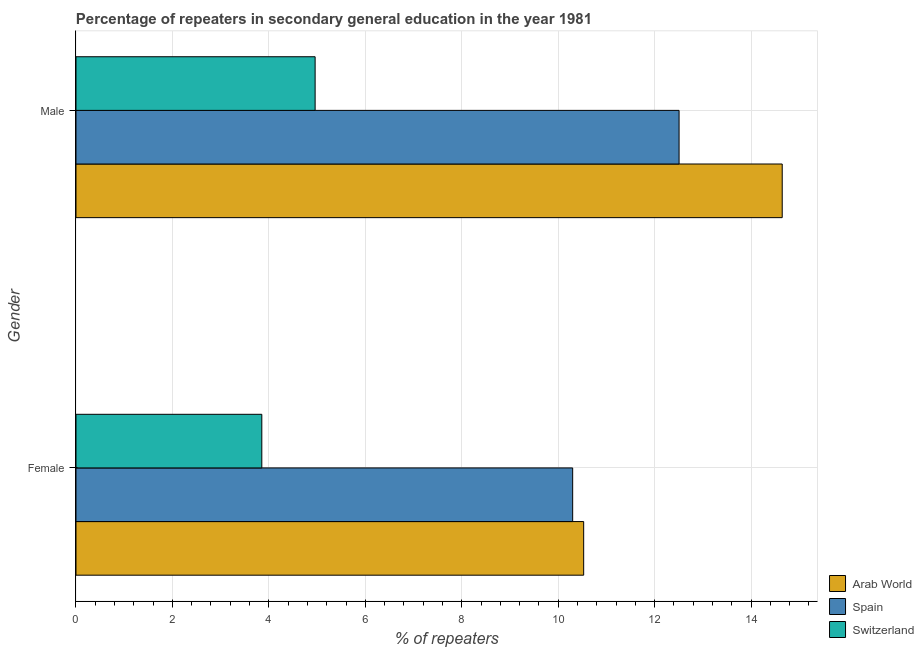How many groups of bars are there?
Your answer should be very brief. 2. How many bars are there on the 2nd tick from the top?
Give a very brief answer. 3. What is the percentage of female repeaters in Arab World?
Ensure brevity in your answer.  10.53. Across all countries, what is the maximum percentage of female repeaters?
Give a very brief answer. 10.53. Across all countries, what is the minimum percentage of female repeaters?
Ensure brevity in your answer.  3.85. In which country was the percentage of male repeaters maximum?
Your response must be concise. Arab World. In which country was the percentage of male repeaters minimum?
Offer a very short reply. Switzerland. What is the total percentage of male repeaters in the graph?
Offer a very short reply. 32.12. What is the difference between the percentage of female repeaters in Switzerland and that in Spain?
Your answer should be compact. -6.45. What is the difference between the percentage of female repeaters in Spain and the percentage of male repeaters in Switzerland?
Offer a very short reply. 5.34. What is the average percentage of female repeaters per country?
Your answer should be compact. 8.23. What is the difference between the percentage of female repeaters and percentage of male repeaters in Arab World?
Provide a succinct answer. -4.12. What is the ratio of the percentage of female repeaters in Spain to that in Switzerland?
Provide a succinct answer. 2.67. Is the percentage of male repeaters in Spain less than that in Switzerland?
Keep it short and to the point. No. What does the 1st bar from the top in Male represents?
Ensure brevity in your answer.  Switzerland. What does the 3rd bar from the bottom in Female represents?
Provide a succinct answer. Switzerland. How many countries are there in the graph?
Your answer should be very brief. 3. What is the difference between two consecutive major ticks on the X-axis?
Keep it short and to the point. 2. Are the values on the major ticks of X-axis written in scientific E-notation?
Your answer should be compact. No. Does the graph contain any zero values?
Make the answer very short. No. Where does the legend appear in the graph?
Ensure brevity in your answer.  Bottom right. How many legend labels are there?
Provide a short and direct response. 3. How are the legend labels stacked?
Make the answer very short. Vertical. What is the title of the graph?
Your response must be concise. Percentage of repeaters in secondary general education in the year 1981. What is the label or title of the X-axis?
Keep it short and to the point. % of repeaters. What is the label or title of the Y-axis?
Your answer should be compact. Gender. What is the % of repeaters in Arab World in Female?
Make the answer very short. 10.53. What is the % of repeaters of Spain in Female?
Offer a very short reply. 10.3. What is the % of repeaters in Switzerland in Female?
Provide a succinct answer. 3.85. What is the % of repeaters of Arab World in Male?
Your answer should be compact. 14.65. What is the % of repeaters of Spain in Male?
Give a very brief answer. 12.51. What is the % of repeaters in Switzerland in Male?
Provide a short and direct response. 4.96. Across all Gender, what is the maximum % of repeaters in Arab World?
Provide a succinct answer. 14.65. Across all Gender, what is the maximum % of repeaters in Spain?
Provide a succinct answer. 12.51. Across all Gender, what is the maximum % of repeaters of Switzerland?
Ensure brevity in your answer.  4.96. Across all Gender, what is the minimum % of repeaters in Arab World?
Offer a very short reply. 10.53. Across all Gender, what is the minimum % of repeaters of Spain?
Make the answer very short. 10.3. Across all Gender, what is the minimum % of repeaters of Switzerland?
Provide a succinct answer. 3.85. What is the total % of repeaters of Arab World in the graph?
Your answer should be compact. 25.18. What is the total % of repeaters of Spain in the graph?
Give a very brief answer. 22.81. What is the total % of repeaters in Switzerland in the graph?
Provide a short and direct response. 8.81. What is the difference between the % of repeaters of Arab World in Female and that in Male?
Your answer should be very brief. -4.12. What is the difference between the % of repeaters of Spain in Female and that in Male?
Keep it short and to the point. -2.21. What is the difference between the % of repeaters in Switzerland in Female and that in Male?
Offer a terse response. -1.11. What is the difference between the % of repeaters in Arab World in Female and the % of repeaters in Spain in Male?
Ensure brevity in your answer.  -1.98. What is the difference between the % of repeaters in Arab World in Female and the % of repeaters in Switzerland in Male?
Offer a terse response. 5.57. What is the difference between the % of repeaters in Spain in Female and the % of repeaters in Switzerland in Male?
Your response must be concise. 5.34. What is the average % of repeaters of Arab World per Gender?
Give a very brief answer. 12.59. What is the average % of repeaters in Spain per Gender?
Provide a short and direct response. 11.4. What is the average % of repeaters of Switzerland per Gender?
Give a very brief answer. 4.41. What is the difference between the % of repeaters of Arab World and % of repeaters of Spain in Female?
Provide a succinct answer. 0.23. What is the difference between the % of repeaters of Arab World and % of repeaters of Switzerland in Female?
Keep it short and to the point. 6.68. What is the difference between the % of repeaters of Spain and % of repeaters of Switzerland in Female?
Offer a very short reply. 6.45. What is the difference between the % of repeaters in Arab World and % of repeaters in Spain in Male?
Your response must be concise. 2.14. What is the difference between the % of repeaters in Arab World and % of repeaters in Switzerland in Male?
Keep it short and to the point. 9.69. What is the difference between the % of repeaters of Spain and % of repeaters of Switzerland in Male?
Provide a succinct answer. 7.55. What is the ratio of the % of repeaters in Arab World in Female to that in Male?
Keep it short and to the point. 0.72. What is the ratio of the % of repeaters of Spain in Female to that in Male?
Your answer should be compact. 0.82. What is the ratio of the % of repeaters in Switzerland in Female to that in Male?
Make the answer very short. 0.78. What is the difference between the highest and the second highest % of repeaters in Arab World?
Your response must be concise. 4.12. What is the difference between the highest and the second highest % of repeaters in Spain?
Keep it short and to the point. 2.21. What is the difference between the highest and the second highest % of repeaters in Switzerland?
Your answer should be very brief. 1.11. What is the difference between the highest and the lowest % of repeaters of Arab World?
Provide a succinct answer. 4.12. What is the difference between the highest and the lowest % of repeaters of Spain?
Make the answer very short. 2.21. What is the difference between the highest and the lowest % of repeaters in Switzerland?
Your response must be concise. 1.11. 